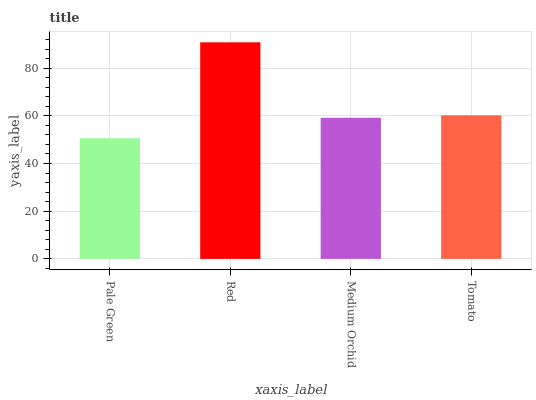Is Pale Green the minimum?
Answer yes or no. Yes. Is Red the maximum?
Answer yes or no. Yes. Is Medium Orchid the minimum?
Answer yes or no. No. Is Medium Orchid the maximum?
Answer yes or no. No. Is Red greater than Medium Orchid?
Answer yes or no. Yes. Is Medium Orchid less than Red?
Answer yes or no. Yes. Is Medium Orchid greater than Red?
Answer yes or no. No. Is Red less than Medium Orchid?
Answer yes or no. No. Is Tomato the high median?
Answer yes or no. Yes. Is Medium Orchid the low median?
Answer yes or no. Yes. Is Medium Orchid the high median?
Answer yes or no. No. Is Red the low median?
Answer yes or no. No. 